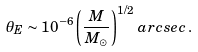Convert formula to latex. <formula><loc_0><loc_0><loc_500><loc_500>\theta _ { E } \sim 1 0 ^ { - 6 } \left ( \frac { M } { M _ { \odot } } \right ) ^ { 1 / 2 } \, a r c s e c \, .</formula> 